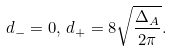Convert formula to latex. <formula><loc_0><loc_0><loc_500><loc_500>d _ { - } & = 0 , \, d _ { + } = 8 \sqrt { \frac { \Delta _ { A } } { 2 \pi } } .</formula> 